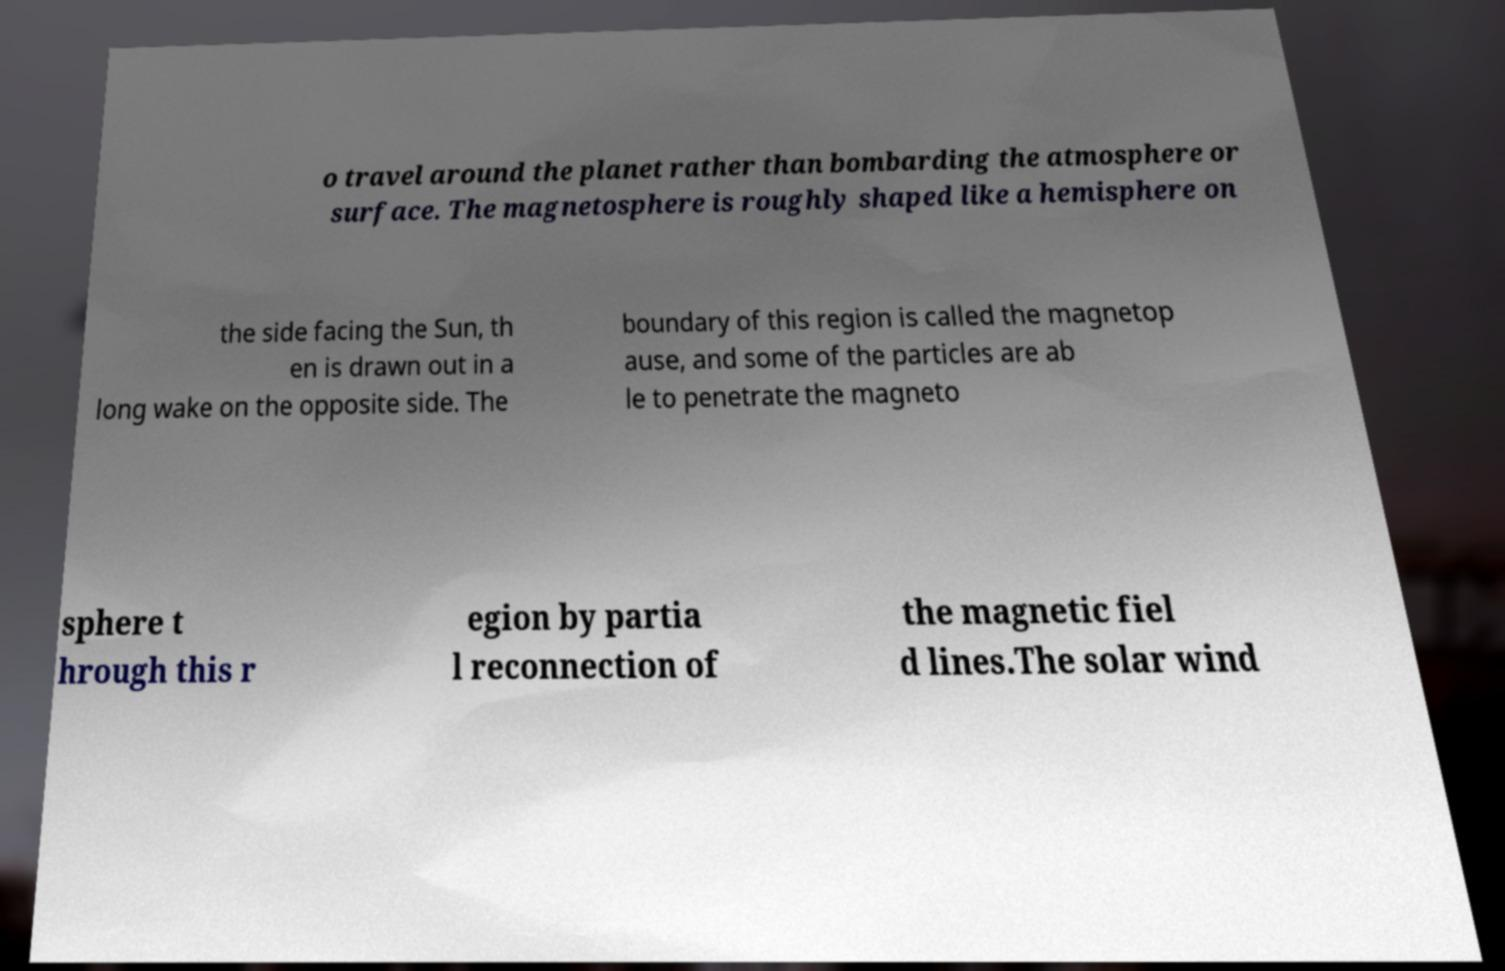There's text embedded in this image that I need extracted. Can you transcribe it verbatim? o travel around the planet rather than bombarding the atmosphere or surface. The magnetosphere is roughly shaped like a hemisphere on the side facing the Sun, th en is drawn out in a long wake on the opposite side. The boundary of this region is called the magnetop ause, and some of the particles are ab le to penetrate the magneto sphere t hrough this r egion by partia l reconnection of the magnetic fiel d lines.The solar wind 